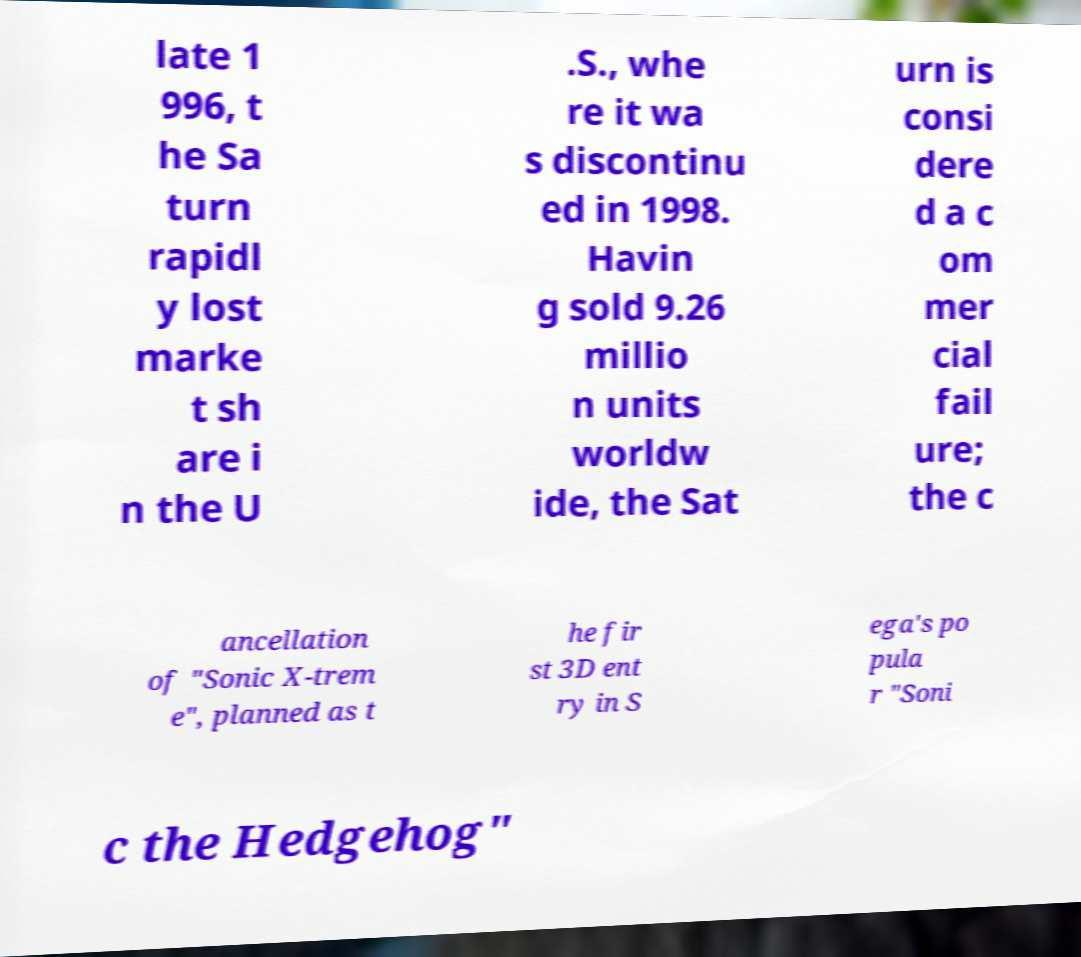There's text embedded in this image that I need extracted. Can you transcribe it verbatim? late 1 996, t he Sa turn rapidl y lost marke t sh are i n the U .S., whe re it wa s discontinu ed in 1998. Havin g sold 9.26 millio n units worldw ide, the Sat urn is consi dere d a c om mer cial fail ure; the c ancellation of "Sonic X-trem e", planned as t he fir st 3D ent ry in S ega's po pula r "Soni c the Hedgehog" 